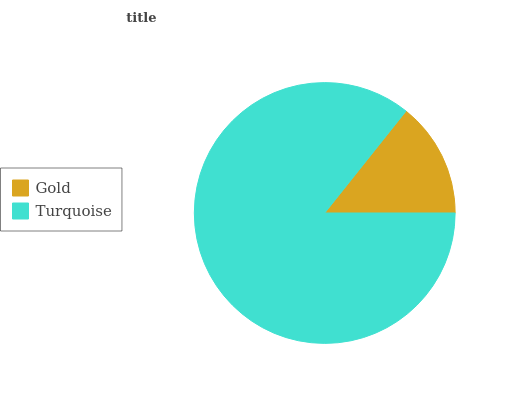Is Gold the minimum?
Answer yes or no. Yes. Is Turquoise the maximum?
Answer yes or no. Yes. Is Turquoise the minimum?
Answer yes or no. No. Is Turquoise greater than Gold?
Answer yes or no. Yes. Is Gold less than Turquoise?
Answer yes or no. Yes. Is Gold greater than Turquoise?
Answer yes or no. No. Is Turquoise less than Gold?
Answer yes or no. No. Is Turquoise the high median?
Answer yes or no. Yes. Is Gold the low median?
Answer yes or no. Yes. Is Gold the high median?
Answer yes or no. No. Is Turquoise the low median?
Answer yes or no. No. 